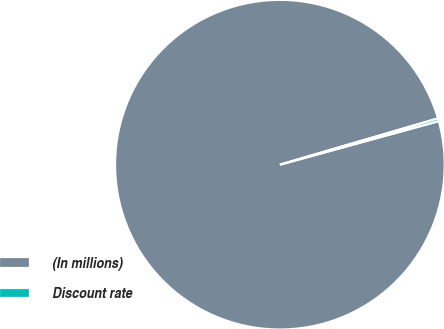<chart> <loc_0><loc_0><loc_500><loc_500><pie_chart><fcel>(In millions)<fcel>Discount rate<nl><fcel>99.73%<fcel>0.27%<nl></chart> 